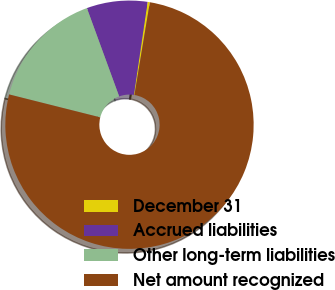Convert chart. <chart><loc_0><loc_0><loc_500><loc_500><pie_chart><fcel>December 31<fcel>Accrued liabilities<fcel>Other long-term liabilities<fcel>Net amount recognized<nl><fcel>0.3%<fcel>7.9%<fcel>15.5%<fcel>76.29%<nl></chart> 